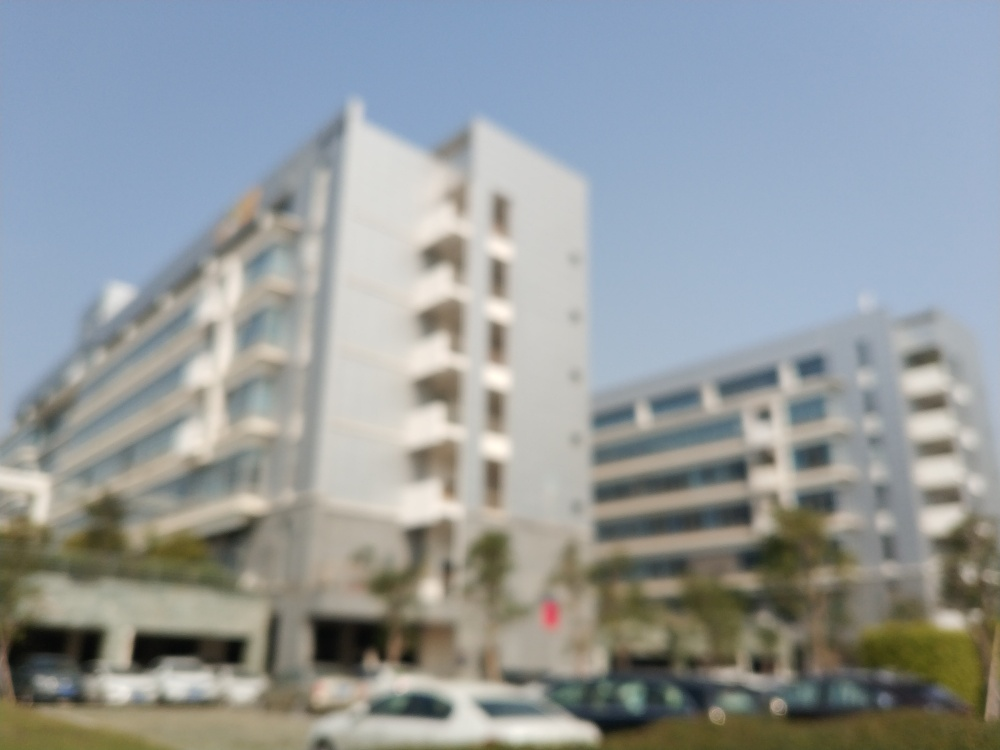What time of day does this image appear to be taken? Based on the brightness and absence of long shadows, it seems the photo was taken around midday when the sun is high. 